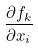Convert formula to latex. <formula><loc_0><loc_0><loc_500><loc_500>\frac { \partial f _ { k } } { \partial x _ { i } }</formula> 